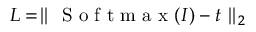Convert formula to latex. <formula><loc_0><loc_0><loc_500><loc_500>L = \| S o f t m a x ( I ) - t \| _ { 2 }</formula> 